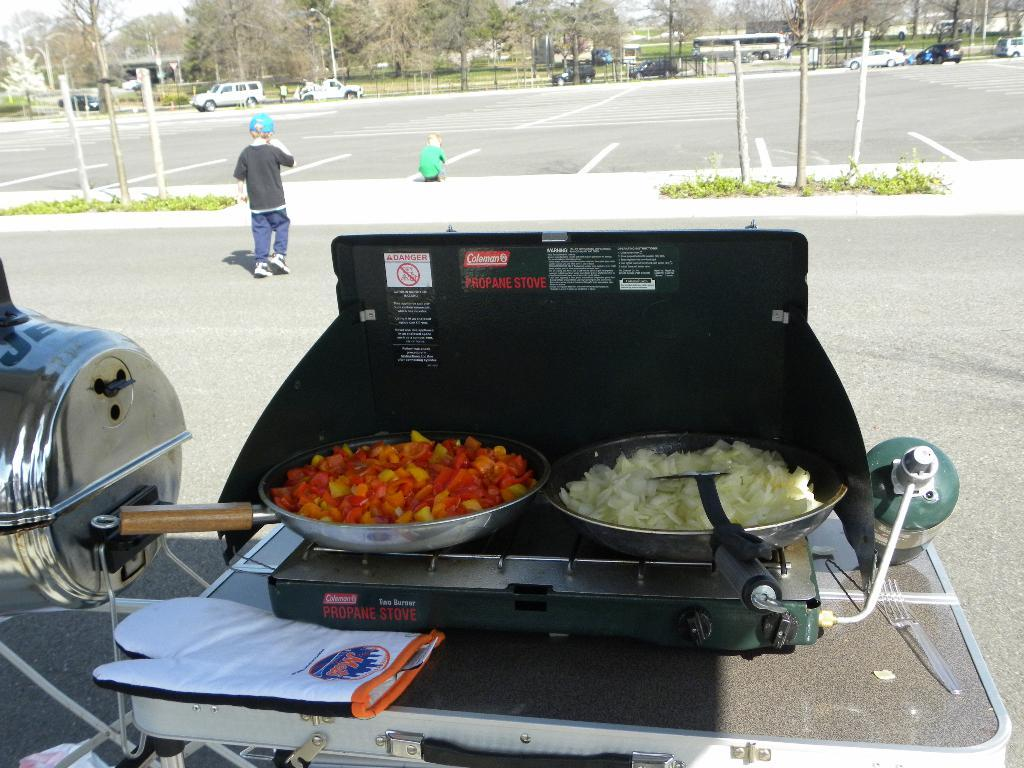<image>
Present a compact description of the photo's key features. The top cover of the grill says propane. 